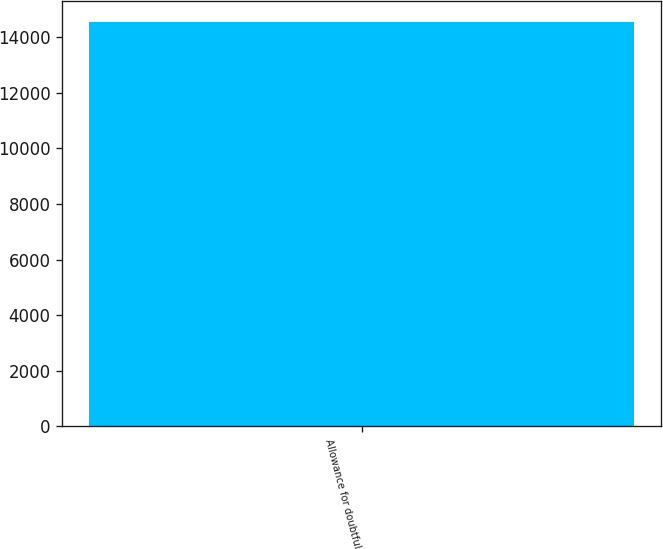<chart> <loc_0><loc_0><loc_500><loc_500><bar_chart><fcel>Allowance for doubtful<nl><fcel>14562<nl></chart> 